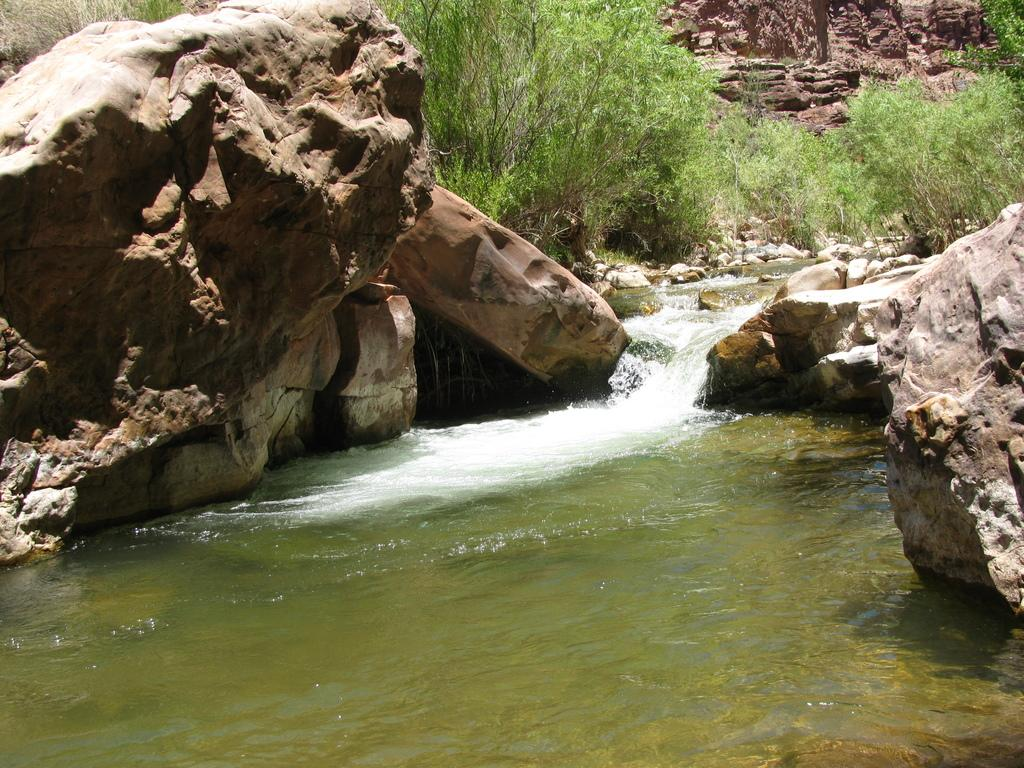What type of natural elements can be seen in the image? There are large stones and water visible in the image. What can be seen in the background of the image? There are plants and trees in the background of the image. What is the cause of death for the person walking in the image? There is no person walking in the image, and therefore no death can be observed. 